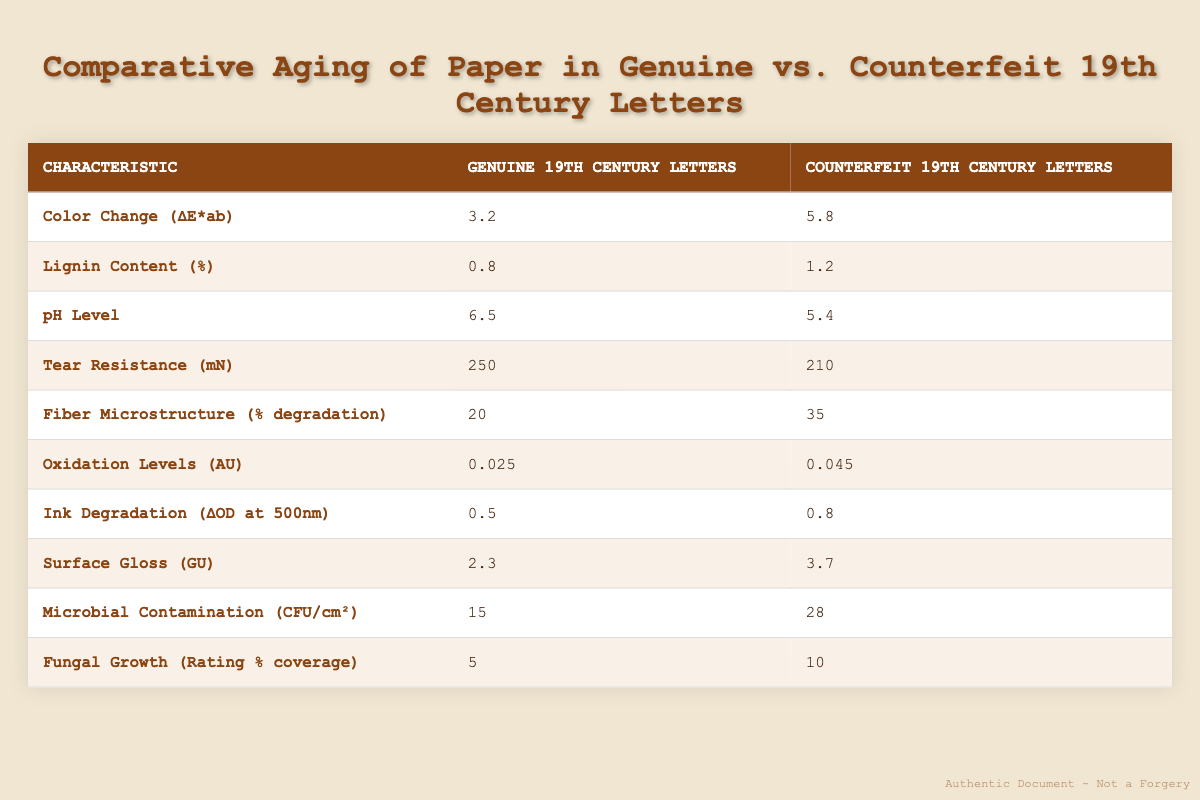What is the pH level of genuine 19th century letters? The pH level of genuine 19th century letters is found directly in the table, listed under the column for Genuine 19th Century Letters. The value is 6.5.
Answer: 6.5 What is the difference in color change between genuine and counterfeit letters? To find the difference in color change, subtract the value for genuine letters from the value for counterfeit letters: 5.8 - 3.2 = 2.6.
Answer: 2.6 Is the lignin content higher in counterfeit or genuine letters? To answer this question, we look at the lignin content for both types of letters in the table. Counterfeit letters have 1.2%, while genuine letters have 0.8%. Since 1.2% is greater than 0.8%, the answer is counterfeit.
Answer: Counterfeit What is the average tear resistance of both genuine and counterfeit letters? The tear resistance for genuine letters is 250 mN and for counterfeit letters is 210 mN. We find the average by adding both values together and dividing by 2: (250 + 210) / 2 = 230 mN.
Answer: 230 mN How does the microbial contamination level of genuine letters compare to counterfeit letters? Genuine letters have 15 CFU/cm² while counterfeit letters have 28 CFU/cm². Since 15 is less than 28, microbial contamination is lower in genuine letters.
Answer: Lower in genuine letters What is the total degradation percentage of fiber microstructure in counterfeit letters compared to that in genuine letters? Genuine letters have 20% degradation and counterfeit letters have 35% degradation. The total degradation in counterfeit letters is found as the sum of these two values: 20 + 35 = 55%.
Answer: 55% Which letter type has higher oxidation levels? The table indicates that genuine letters have an oxidation level of 0.025 AU, while counterfeit letters have 0.045 AU. Since 0.045 AU is greater than 0.025 AU, counterfeit letters have higher oxidation levels.
Answer: Counterfeit How many more microbial contamination units are present in counterfeit letters than in genuine letters? To find the difference in microbial contamination, subtract the value for genuine letters from the value for counterfeit letters: 28 - 15 = 13.
Answer: 13 What percentage of fungal growth is recorded for genuine 19th century letters? The table specifies that fungal growth for genuine letters is rated at 5% coverage, which can be found in the corresponding row under the column for Genuine 19th Century Letters.
Answer: 5% 